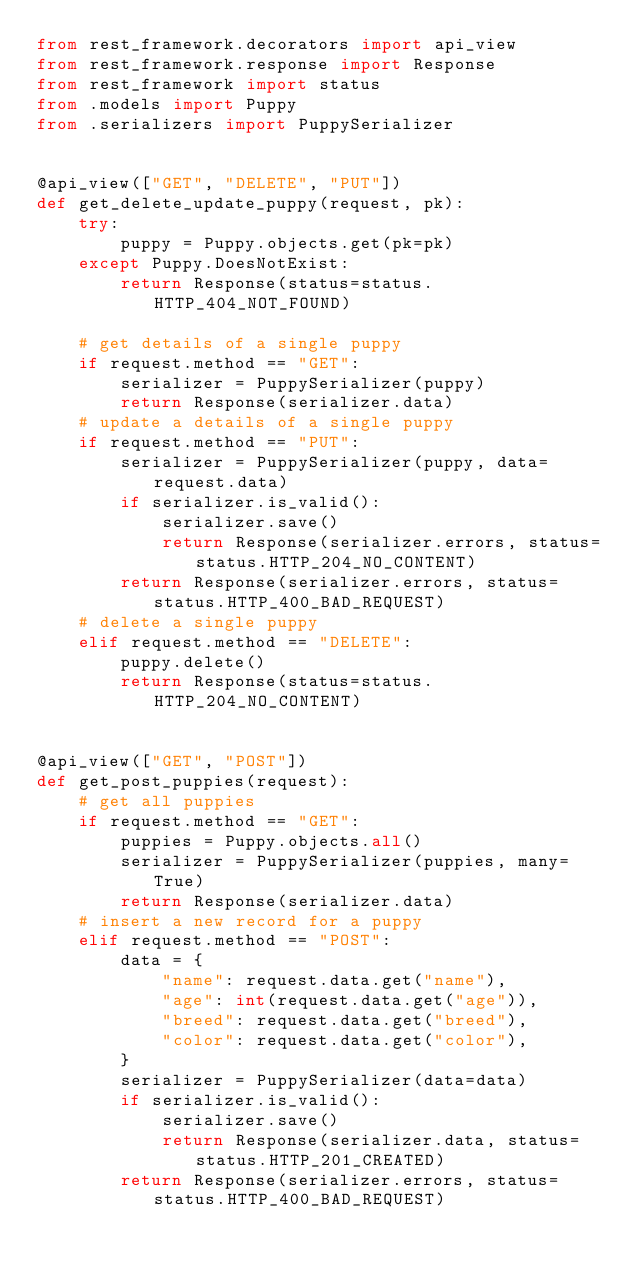<code> <loc_0><loc_0><loc_500><loc_500><_Python_>from rest_framework.decorators import api_view
from rest_framework.response import Response
from rest_framework import status
from .models import Puppy
from .serializers import PuppySerializer


@api_view(["GET", "DELETE", "PUT"])
def get_delete_update_puppy(request, pk):
    try:
        puppy = Puppy.objects.get(pk=pk)
    except Puppy.DoesNotExist:
        return Response(status=status.HTTP_404_NOT_FOUND)

    # get details of a single puppy
    if request.method == "GET":
        serializer = PuppySerializer(puppy)
        return Response(serializer.data)
    # update a details of a single puppy
    if request.method == "PUT":
        serializer = PuppySerializer(puppy, data=request.data)
        if serializer.is_valid():
            serializer.save()
            return Response(serializer.errors, status=status.HTTP_204_NO_CONTENT)
        return Response(serializer.errors, status=status.HTTP_400_BAD_REQUEST)
    # delete a single puppy
    elif request.method == "DELETE":
        puppy.delete()
        return Response(status=status.HTTP_204_NO_CONTENT)


@api_view(["GET", "POST"])
def get_post_puppies(request):
    # get all puppies
    if request.method == "GET":
        puppies = Puppy.objects.all()
        serializer = PuppySerializer(puppies, many=True)
        return Response(serializer.data)
    # insert a new record for a puppy
    elif request.method == "POST":
        data = {
            "name": request.data.get("name"),
            "age": int(request.data.get("age")),
            "breed": request.data.get("breed"),
            "color": request.data.get("color"),
        }
        serializer = PuppySerializer(data=data)
        if serializer.is_valid():
            serializer.save()
            return Response(serializer.data, status=status.HTTP_201_CREATED)
        return Response(serializer.errors, status=status.HTTP_400_BAD_REQUEST)
</code> 